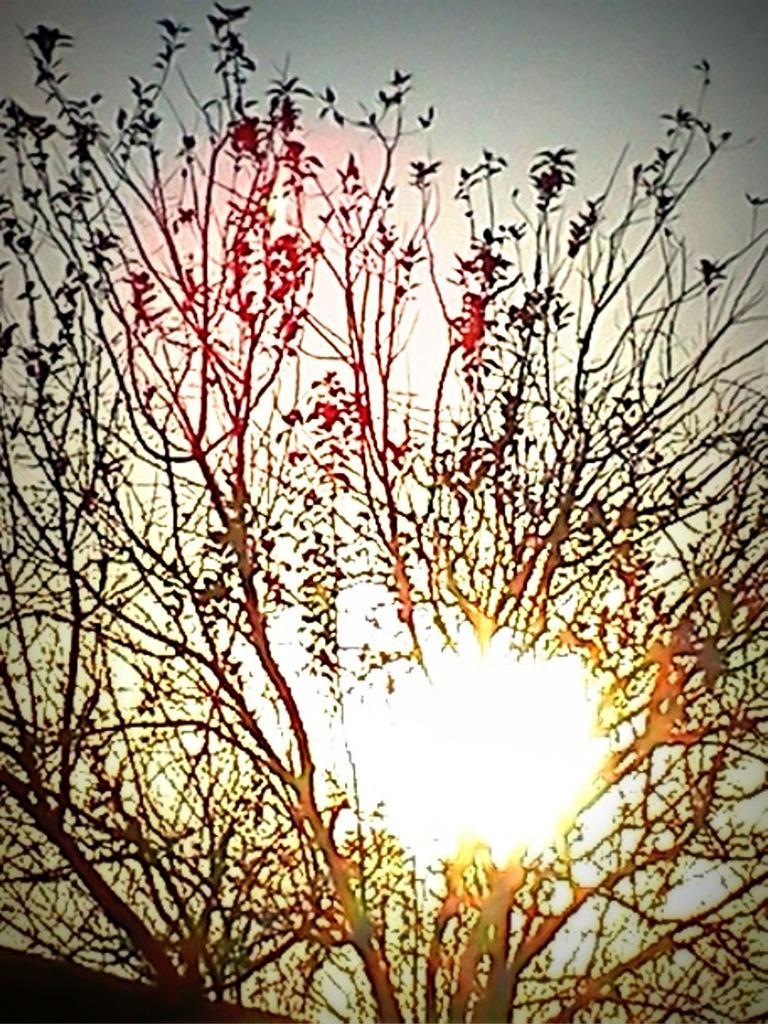How would you summarize this image in a sentence or two? In this picture there are trees in the foreground. At the top there is sky and there is a sun. 